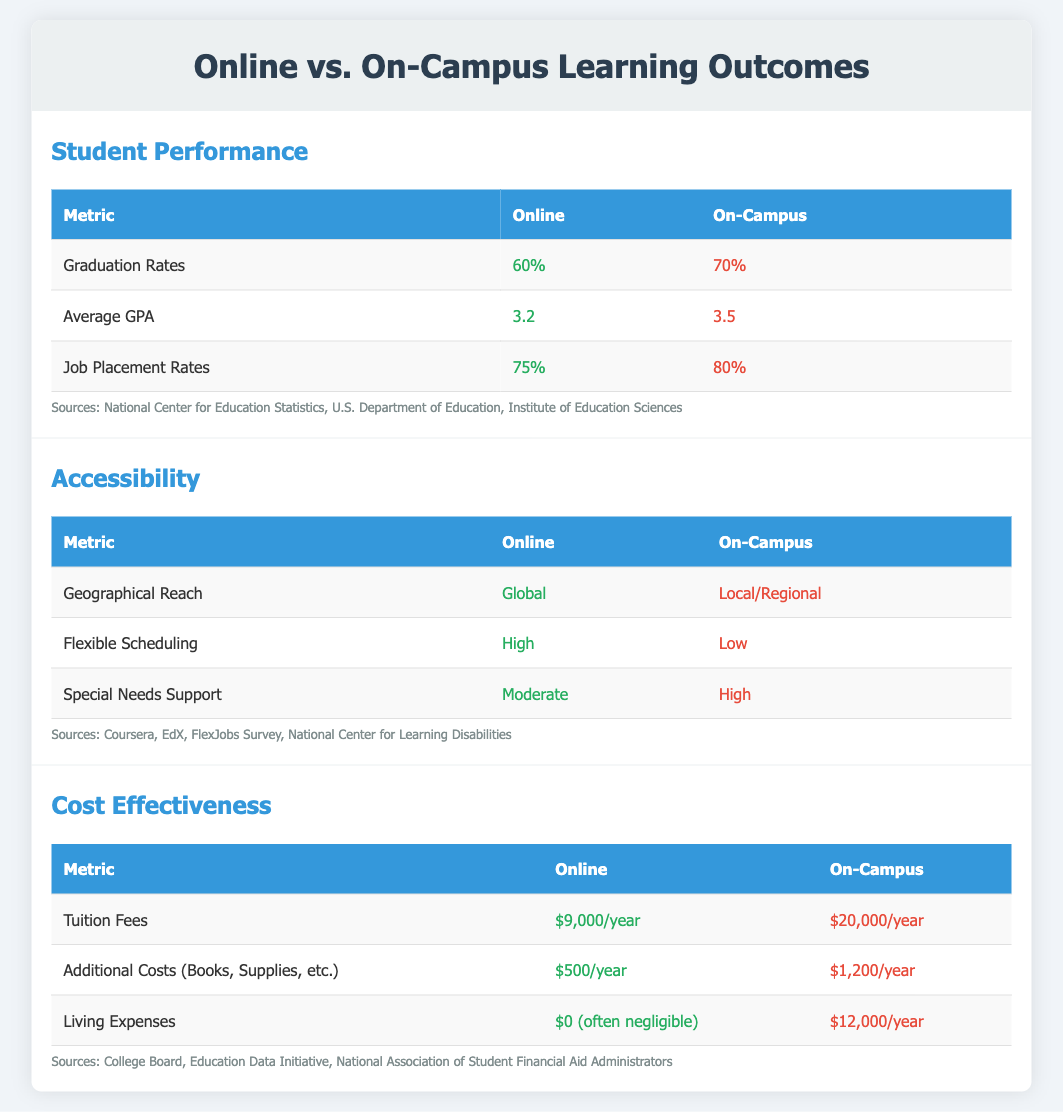what is the graduation rate for Online learning? The graduation rate for Online learning is 60% as indicated in the student performance section.
Answer: 60% what is the average GPA for On-Campus learning? The average GPA for On-Campus learning is 3.5, based on the performance metrics provided.
Answer: 3.5 how much are the tuition fees for Online programs? The tuition fees for Online programs are $9,000/year, as specified in the cost-effectiveness section.
Answer: $9,000/year what is the job placement rate for On-Campus learning? The job placement rate for On-Campus learning is 80%, shown in the student performance comparison.
Answer: 80% how does the geographical reach of Online learning compare to On-Campus learning? Online learning has a global geographical reach, while On-Campus learning is restricted to local/regional areas.
Answer: Global / Local/Regional what is the additional cost for books and supplies for On-Campus learning? The additional cost for books and supplies for On-Campus learning is $1,200/year according to the cost-effectiveness metrics.
Answer: $1,200/year which learning format has higher special needs support? On-Campus learning has higher special needs support as per the accessibility metrics outlined.
Answer: On-Campus what is the average living expense for Online learning? The average living expense for Online learning is $0 (often negligible) as stated in the cost comparison.
Answer: $0 (often negligible) which learning format provides high flexible scheduling? The Online learning format provides high flexible scheduling, based on the accessibility section.
Answer: High 